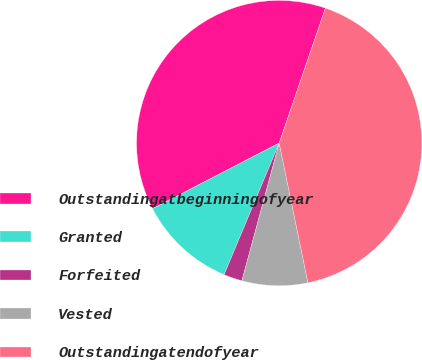Convert chart. <chart><loc_0><loc_0><loc_500><loc_500><pie_chart><fcel>Outstandingatbeginningofyear<fcel>Granted<fcel>Forfeited<fcel>Vested<fcel>Outstandingatendofyear<nl><fcel>37.86%<fcel>11.08%<fcel>2.1%<fcel>7.44%<fcel>41.51%<nl></chart> 